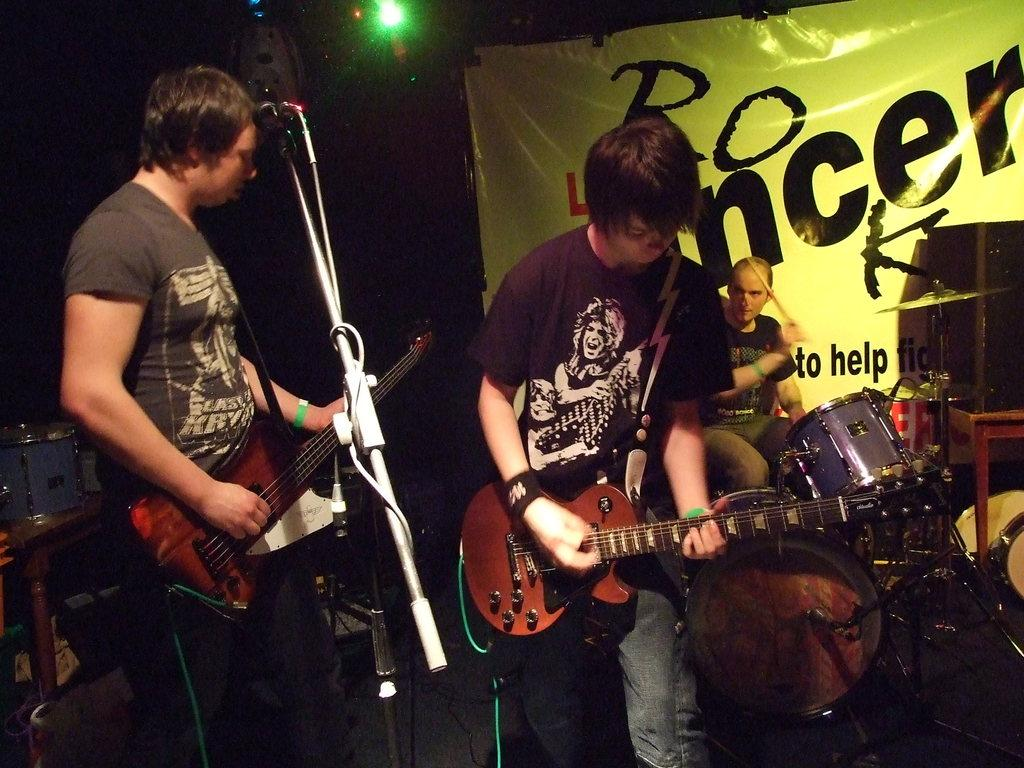What type of performance is taking place in the image? There is a rock band performing on a stage in the image. How many members of the band are playing guitar? Two members of the band are playing guitar. What instrument is the third member of the band playing? One member of the band is playing drums. Can you describe the lighting setup for the performance? There is a light focusing on the band from the top and behind. Can you see any seashore or crib in the image? No, there is no seashore or crib present in the image; it features a rock band performing on a stage. What type of power source is being used by the band during the performance? The image does not provide information about the power source being used by the band during the performance. 